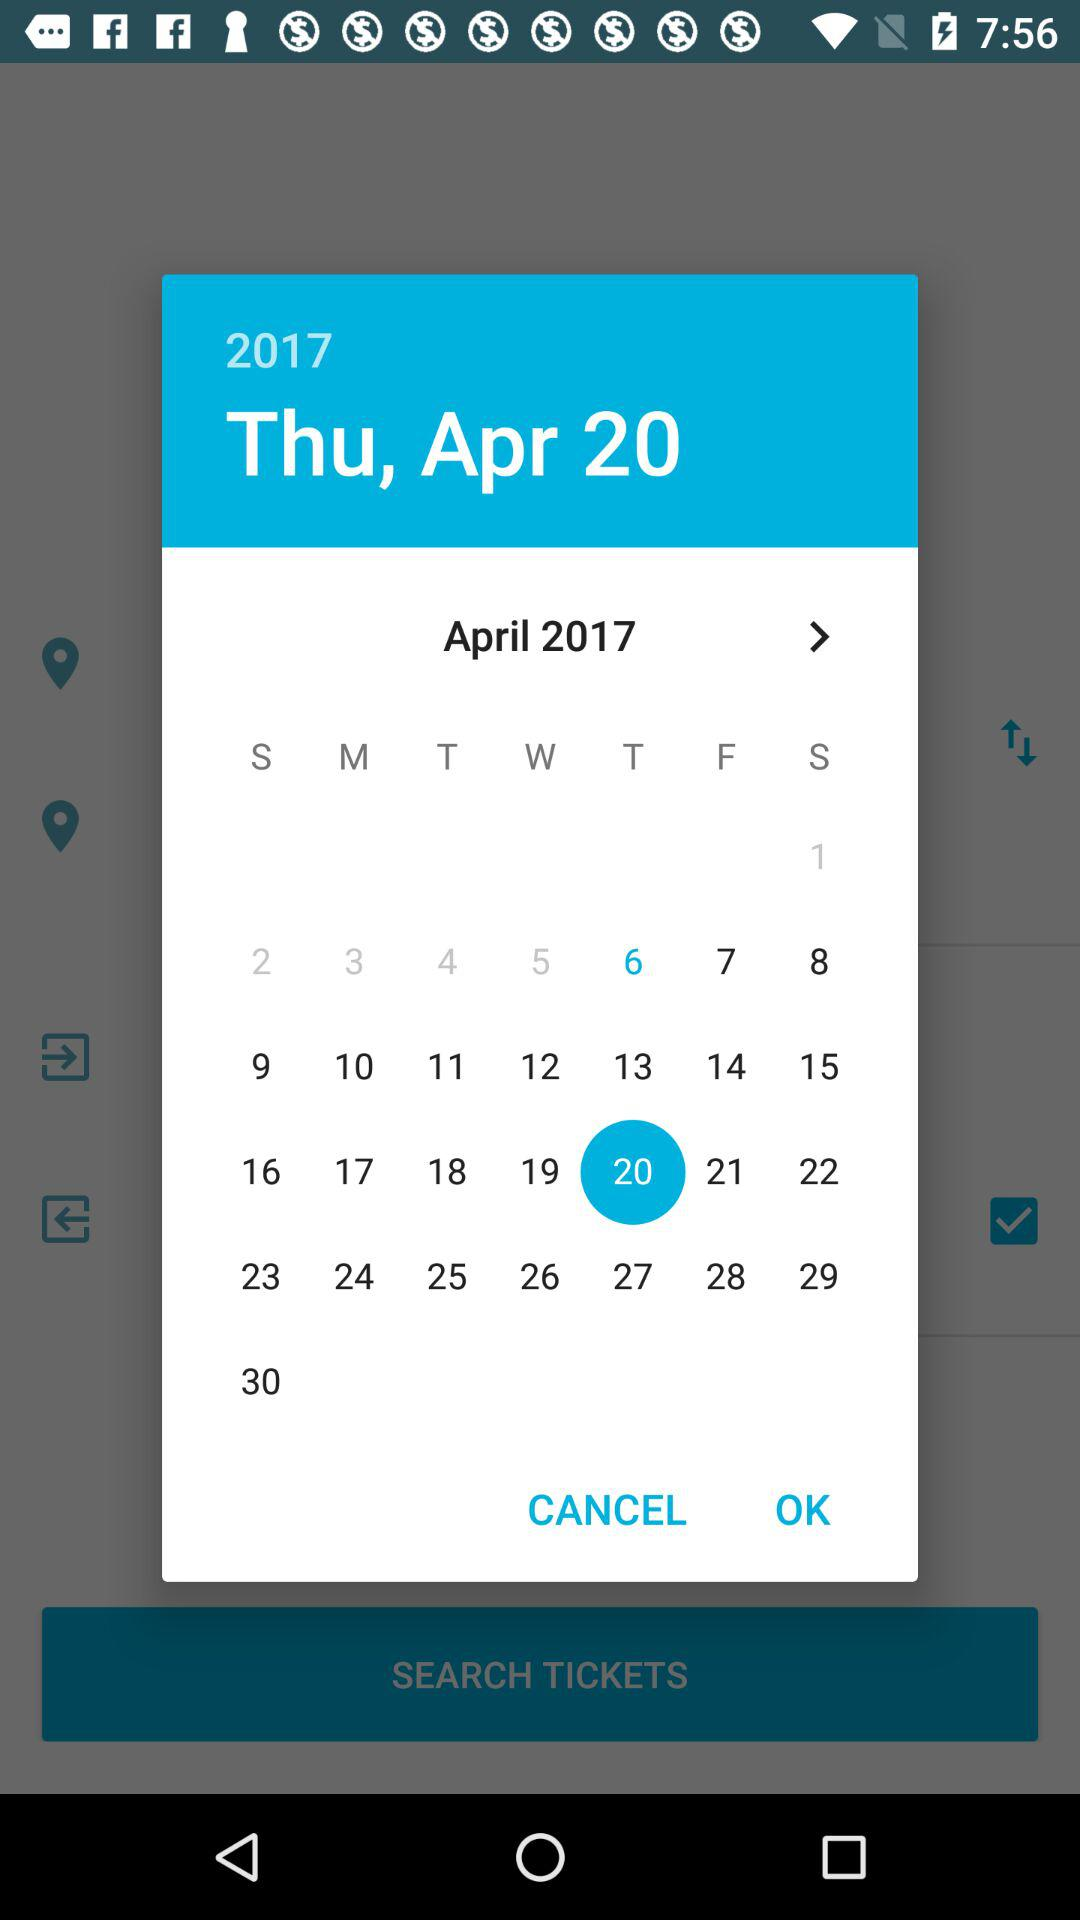What year's calendar is this? The calendar is of the year 2017. 